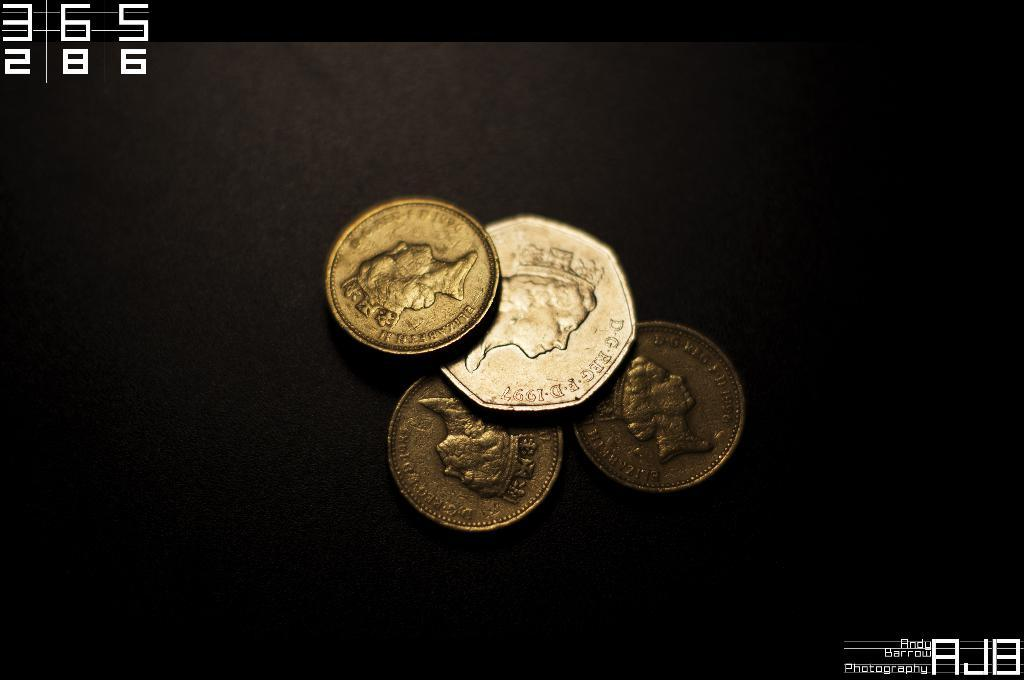<image>
Provide a brief description of the given image. Some UK  coins with Elizabeth II written on the edge 